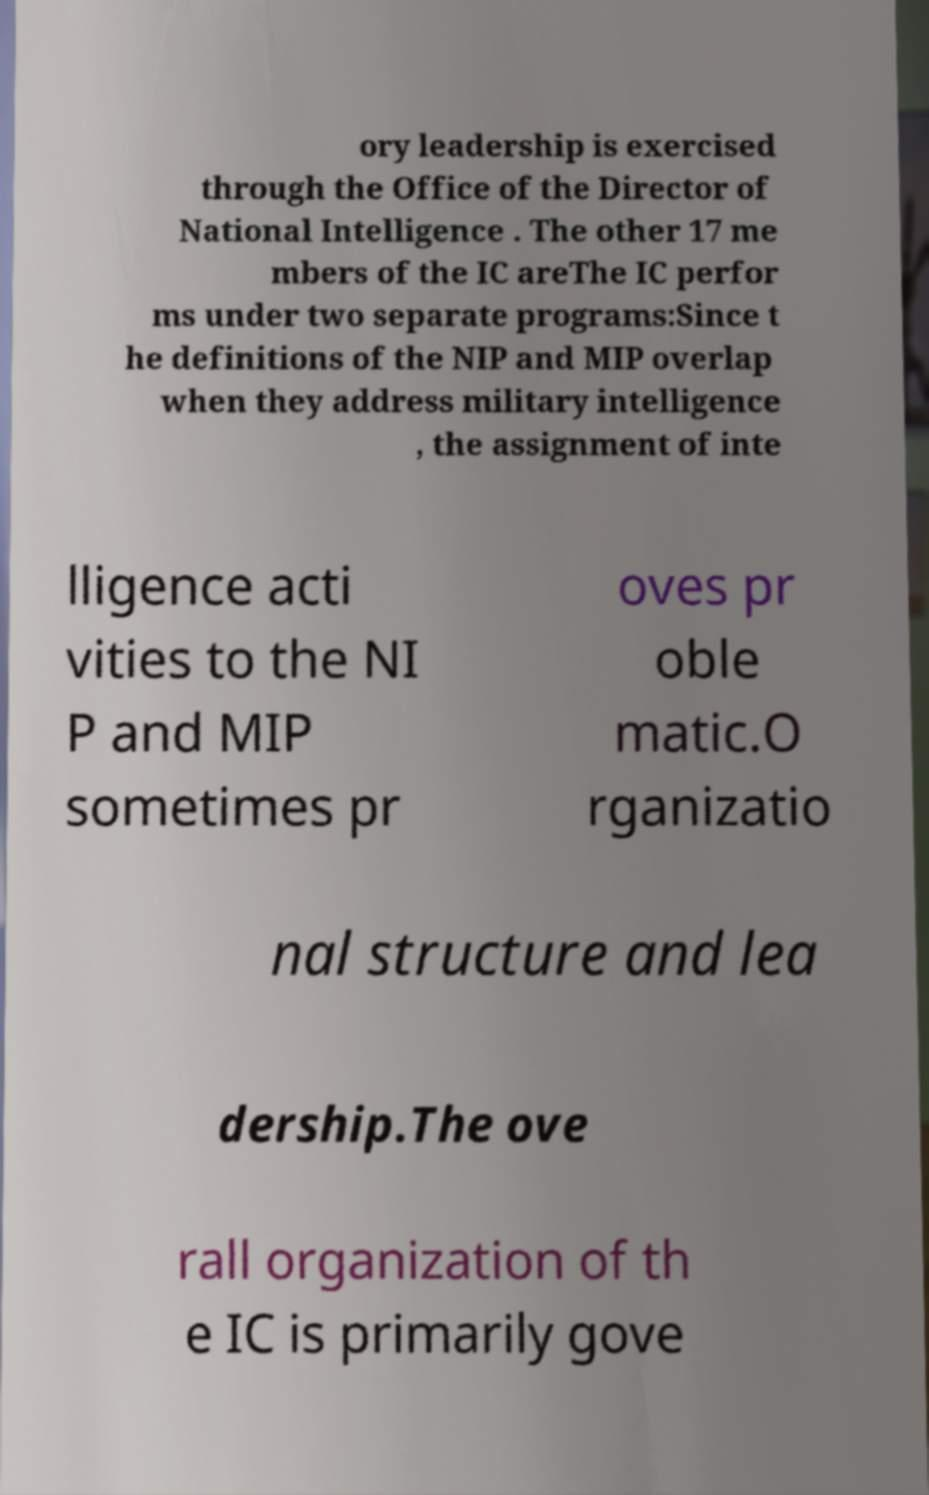I need the written content from this picture converted into text. Can you do that? ory leadership is exercised through the Office of the Director of National Intelligence . The other 17 me mbers of the IC areThe IC perfor ms under two separate programs:Since t he definitions of the NIP and MIP overlap when they address military intelligence , the assignment of inte lligence acti vities to the NI P and MIP sometimes pr oves pr oble matic.O rganizatio nal structure and lea dership.The ove rall organization of th e IC is primarily gove 